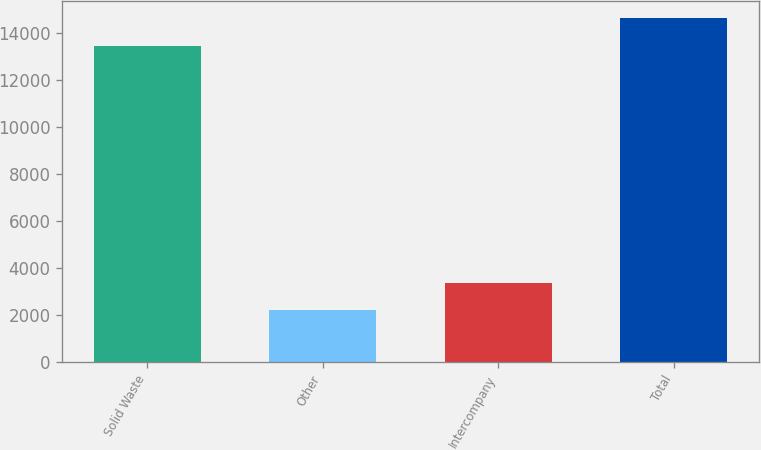Convert chart to OTSL. <chart><loc_0><loc_0><loc_500><loc_500><bar_chart><fcel>Solid Waste<fcel>Other<fcel>Intercompany<fcel>Total<nl><fcel>13449<fcel>2191<fcel>3371.5<fcel>14629.5<nl></chart> 